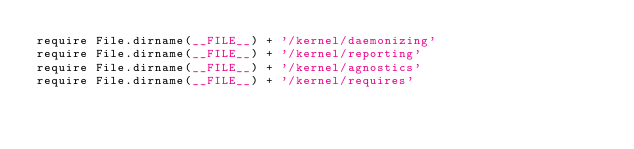<code> <loc_0><loc_0><loc_500><loc_500><_Ruby_>require File.dirname(__FILE__) + '/kernel/daemonizing'
require File.dirname(__FILE__) + '/kernel/reporting'
require File.dirname(__FILE__) + '/kernel/agnostics'
require File.dirname(__FILE__) + '/kernel/requires'
</code> 